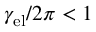<formula> <loc_0><loc_0><loc_500><loc_500>\gamma _ { e l } / 2 \pi < 1</formula> 